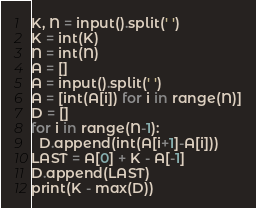Convert code to text. <code><loc_0><loc_0><loc_500><loc_500><_Python_>K, N = input().split(' ')
K = int(K)
N = int(N)
A = []
A = input().split(' ')
A = [int(A[i]) for i in range(N)]
D = []
for i in range(N-1):
  D.append(int(A[i+1]-A[i]))
LAST = A[0] + K - A[-1]
D.append(LAST)
print(K - max(D))</code> 